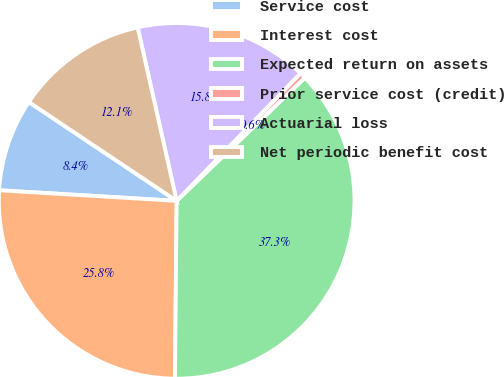<chart> <loc_0><loc_0><loc_500><loc_500><pie_chart><fcel>Service cost<fcel>Interest cost<fcel>Expected return on assets<fcel>Prior service cost (credit)<fcel>Actuarial loss<fcel>Net periodic benefit cost<nl><fcel>8.43%<fcel>25.8%<fcel>37.33%<fcel>0.56%<fcel>15.78%<fcel>12.1%<nl></chart> 